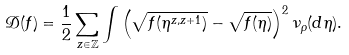<formula> <loc_0><loc_0><loc_500><loc_500>\mathcal { D } ( f ) = \frac { 1 } { 2 } \sum _ { z \in \mathbb { Z } } \int \left ( \sqrt { f ( \eta ^ { z , z + 1 } ) } - \sqrt { f ( \eta ) } \right ) ^ { 2 } \nu _ { \rho } ( d \eta ) .</formula> 